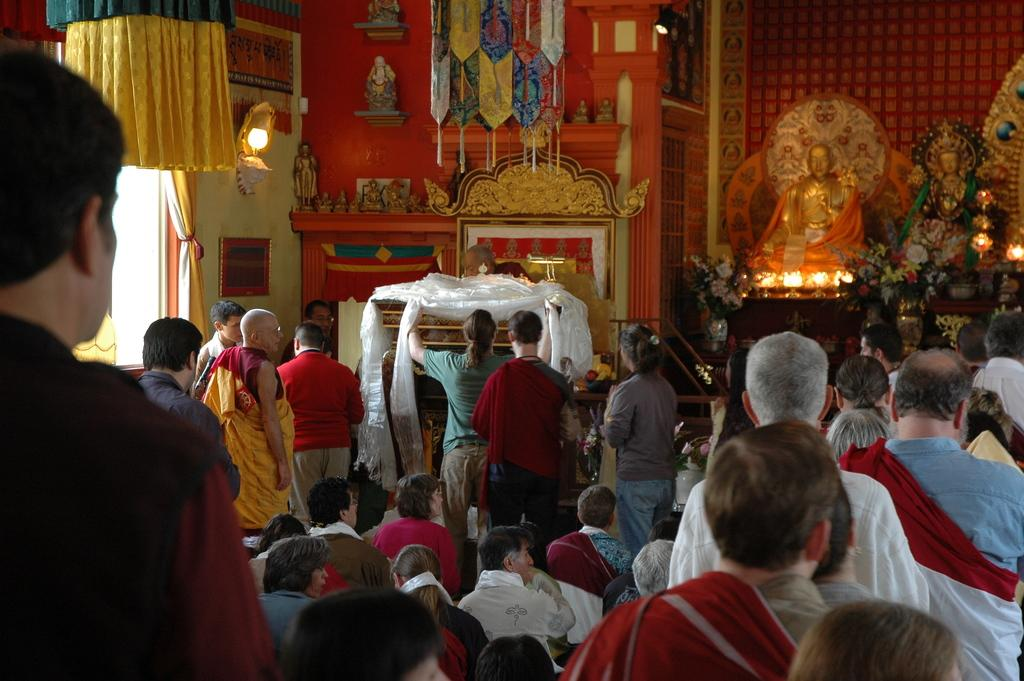What are the people in the image doing? Some people are standing, while others are sitting in the image. What else can be seen in the image besides people? There are sculptures in the image. Can you describe the light source in the image? There is a light source in the image, but its specific details are not mentioned. What is on the wall in the image? There is a photo frame on the wall in the image. What type of butter is being used to decorate the sculptures in the image? There is no butter present in the image, and the sculptures are not being decorated. 